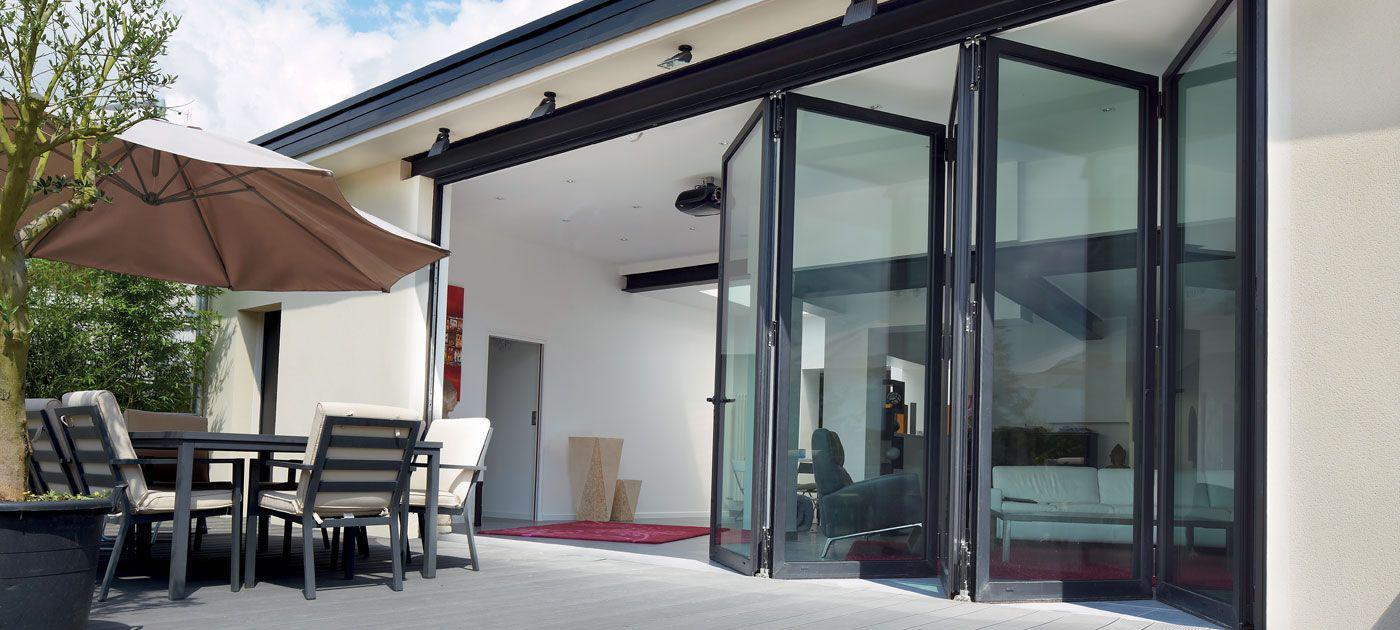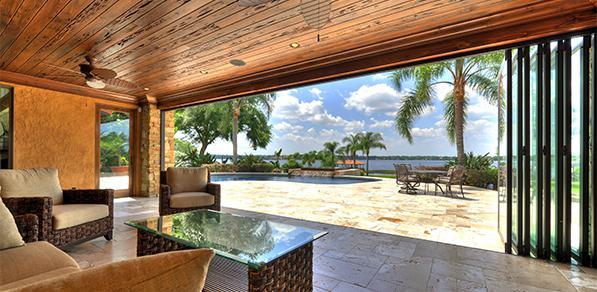The first image is the image on the left, the second image is the image on the right. Assess this claim about the two images: "An image shows a room with accordion-type sliding doors that are at least partly open, revealing a room-length view of natural scenery.". Correct or not? Answer yes or no. Yes. The first image is the image on the left, the second image is the image on the right. For the images displayed, is the sentence "In at least one image there is a six parily open glass door panels attached to each other." factually correct? Answer yes or no. Yes. 